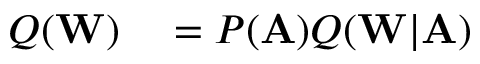Convert formula to latex. <formula><loc_0><loc_0><loc_500><loc_500>\begin{array} { r l } { Q ( W ) } & = P ( A ) Q ( W | A ) } \end{array}</formula> 